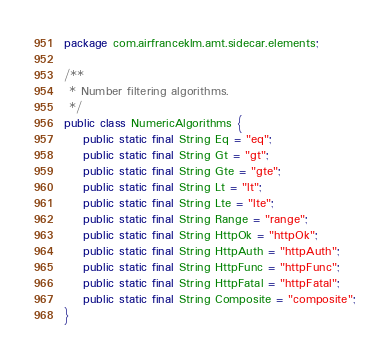Convert code to text. <code><loc_0><loc_0><loc_500><loc_500><_Java_>package com.airfranceklm.amt.sidecar.elements;

/**
 * Number filtering algorithms.
 */
public class NumericAlgorithms {
    public static final String Eq = "eq";
    public static final String Gt = "gt";
    public static final String Gte = "gte";
    public static final String Lt = "lt";
    public static final String Lte = "lte";
    public static final String Range = "range";
    public static final String HttpOk = "httpOk";
    public static final String HttpAuth = "httpAuth";
    public static final String HttpFunc = "httpFunc";
    public static final String HttpFatal = "httpFatal";
    public static final String Composite = "composite";
}
</code> 